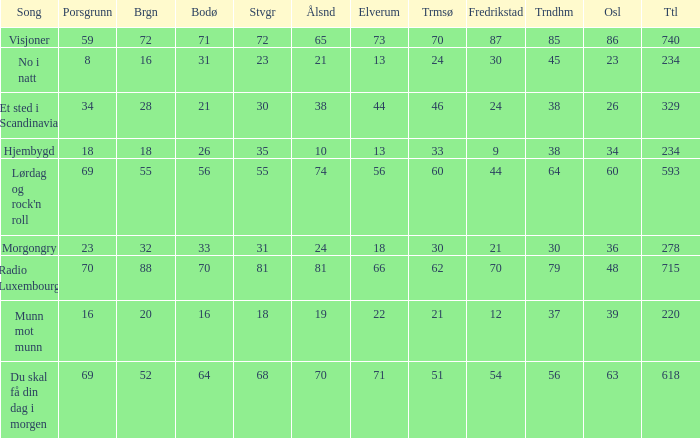When oslo is 48, what is stavanger? 81.0. 